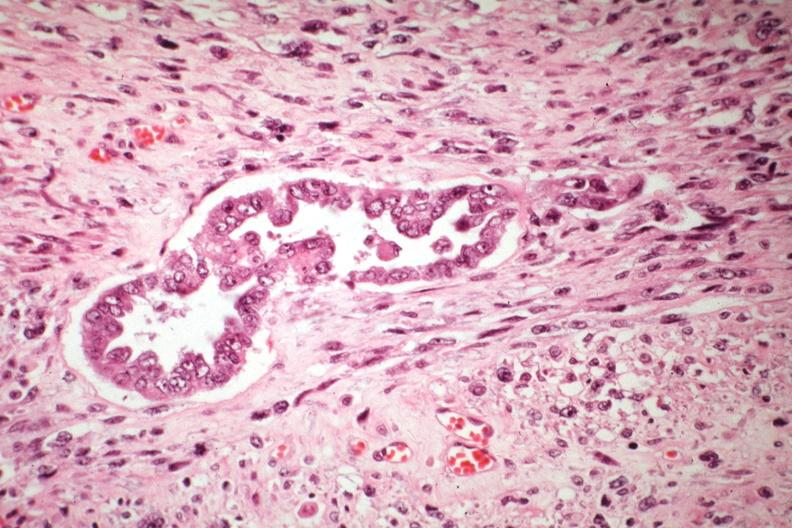what well shown?
Answer the question using a single word or phrase. Malignant gland and stoma 